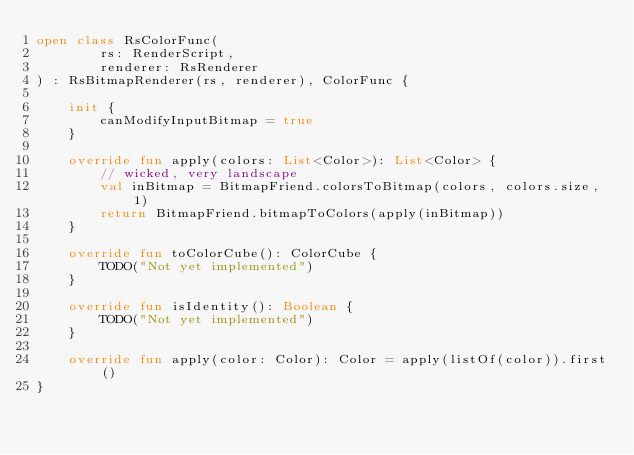<code> <loc_0><loc_0><loc_500><loc_500><_Kotlin_>open class RsColorFunc(
        rs: RenderScript,
        renderer: RsRenderer
) : RsBitmapRenderer(rs, renderer), ColorFunc {

    init {
        canModifyInputBitmap = true
    }

    override fun apply(colors: List<Color>): List<Color> {
        // wicked, very landscape
        val inBitmap = BitmapFriend.colorsToBitmap(colors, colors.size, 1)
        return BitmapFriend.bitmapToColors(apply(inBitmap))
    }

    override fun toColorCube(): ColorCube {
        TODO("Not yet implemented")
    }

    override fun isIdentity(): Boolean {
        TODO("Not yet implemented")
    }

    override fun apply(color: Color): Color = apply(listOf(color)).first()
}
</code> 